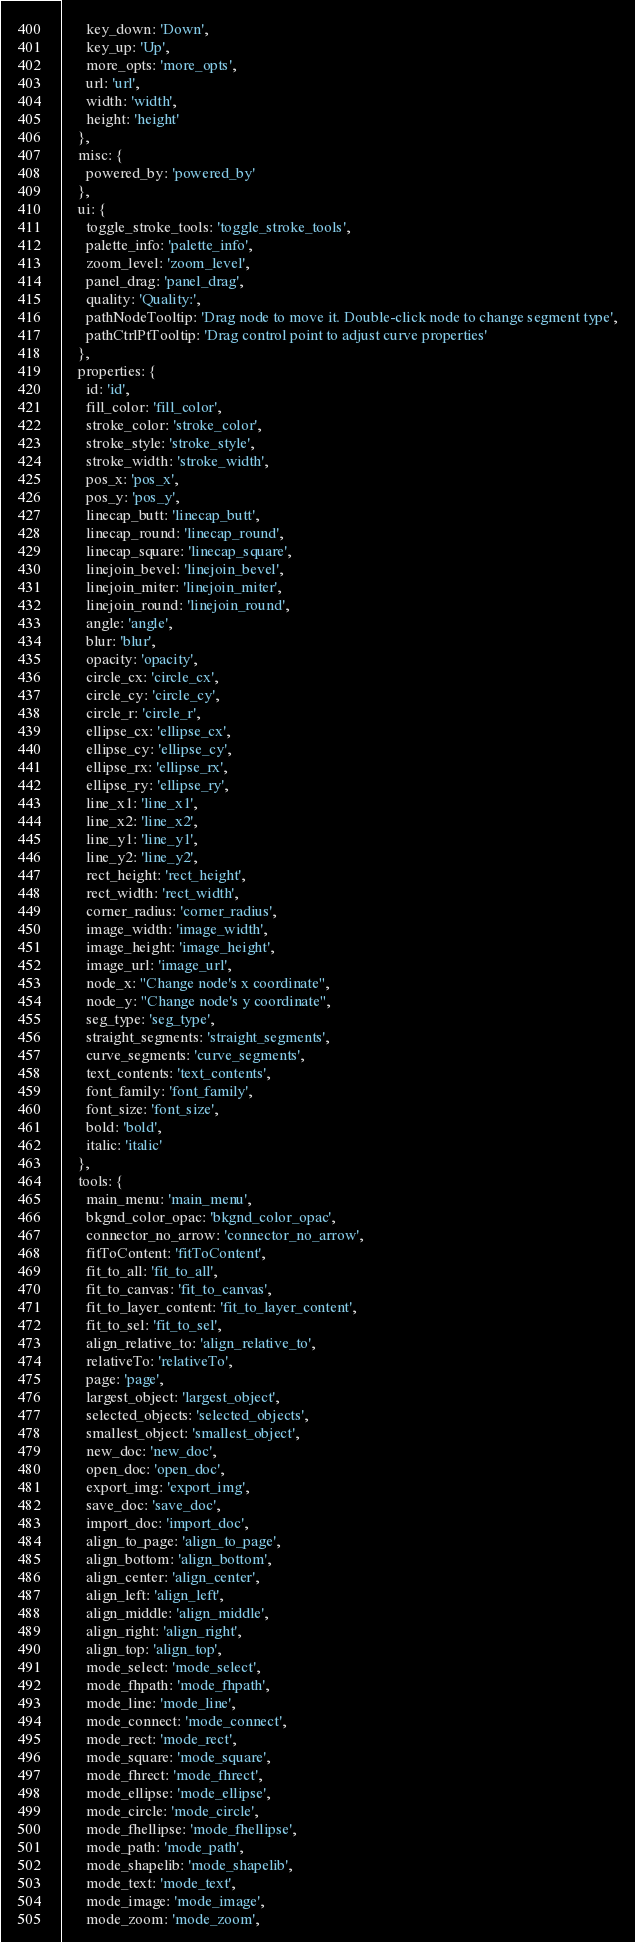<code> <loc_0><loc_0><loc_500><loc_500><_JavaScript_>      key_down: 'Down',
      key_up: 'Up',
      more_opts: 'more_opts',
      url: 'url',
      width: 'width',
      height: 'height'
    },
    misc: {
      powered_by: 'powered_by'
    },
    ui: {
      toggle_stroke_tools: 'toggle_stroke_tools',
      palette_info: 'palette_info',
      zoom_level: 'zoom_level',
      panel_drag: 'panel_drag',
      quality: 'Quality:',
      pathNodeTooltip: 'Drag node to move it. Double-click node to change segment type',
      pathCtrlPtTooltip: 'Drag control point to adjust curve properties'
    },
    properties: {
      id: 'id',
      fill_color: 'fill_color',
      stroke_color: 'stroke_color',
      stroke_style: 'stroke_style',
      stroke_width: 'stroke_width',
      pos_x: 'pos_x',
      pos_y: 'pos_y',
      linecap_butt: 'linecap_butt',
      linecap_round: 'linecap_round',
      linecap_square: 'linecap_square',
      linejoin_bevel: 'linejoin_bevel',
      linejoin_miter: 'linejoin_miter',
      linejoin_round: 'linejoin_round',
      angle: 'angle',
      blur: 'blur',
      opacity: 'opacity',
      circle_cx: 'circle_cx',
      circle_cy: 'circle_cy',
      circle_r: 'circle_r',
      ellipse_cx: 'ellipse_cx',
      ellipse_cy: 'ellipse_cy',
      ellipse_rx: 'ellipse_rx',
      ellipse_ry: 'ellipse_ry',
      line_x1: 'line_x1',
      line_x2: 'line_x2',
      line_y1: 'line_y1',
      line_y2: 'line_y2',
      rect_height: 'rect_height',
      rect_width: 'rect_width',
      corner_radius: 'corner_radius',
      image_width: 'image_width',
      image_height: 'image_height',
      image_url: 'image_url',
      node_x: "Change node's x coordinate",
      node_y: "Change node's y coordinate",
      seg_type: 'seg_type',
      straight_segments: 'straight_segments',
      curve_segments: 'curve_segments',
      text_contents: 'text_contents',
      font_family: 'font_family',
      font_size: 'font_size',
      bold: 'bold',
      italic: 'italic'
    },
    tools: {
      main_menu: 'main_menu',
      bkgnd_color_opac: 'bkgnd_color_opac',
      connector_no_arrow: 'connector_no_arrow',
      fitToContent: 'fitToContent',
      fit_to_all: 'fit_to_all',
      fit_to_canvas: 'fit_to_canvas',
      fit_to_layer_content: 'fit_to_layer_content',
      fit_to_sel: 'fit_to_sel',
      align_relative_to: 'align_relative_to',
      relativeTo: 'relativeTo',
      page: 'page',
      largest_object: 'largest_object',
      selected_objects: 'selected_objects',
      smallest_object: 'smallest_object',
      new_doc: 'new_doc',
      open_doc: 'open_doc',
      export_img: 'export_img',
      save_doc: 'save_doc',
      import_doc: 'import_doc',
      align_to_page: 'align_to_page',
      align_bottom: 'align_bottom',
      align_center: 'align_center',
      align_left: 'align_left',
      align_middle: 'align_middle',
      align_right: 'align_right',
      align_top: 'align_top',
      mode_select: 'mode_select',
      mode_fhpath: 'mode_fhpath',
      mode_line: 'mode_line',
      mode_connect: 'mode_connect',
      mode_rect: 'mode_rect',
      mode_square: 'mode_square',
      mode_fhrect: 'mode_fhrect',
      mode_ellipse: 'mode_ellipse',
      mode_circle: 'mode_circle',
      mode_fhellipse: 'mode_fhellipse',
      mode_path: 'mode_path',
      mode_shapelib: 'mode_shapelib',
      mode_text: 'mode_text',
      mode_image: 'mode_image',
      mode_zoom: 'mode_zoom',</code> 